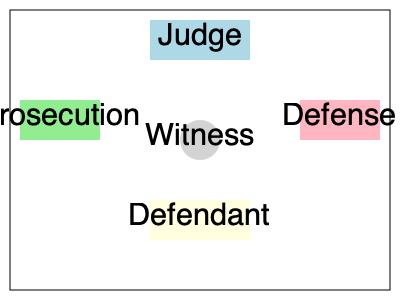In an international immigration hearing, the courtroom is arranged as shown in the diagram. If the judge needs to maintain direct line of sight with all parties, and the witness stand needs to be repositioned to accommodate a language interpreter, which position would be most suitable for the interpreter without obstructing the judge's view? To solve this problem, we need to consider the following steps:

1. Identify the current positions of all parties in the courtroom:
   - Judge: Center-top
   - Prosecution: Left side
   - Defense: Right side
   - Defendant: Center-bottom
   - Witness: Center

2. Understand the requirements:
   - The judge must maintain a direct line of sight with all parties
   - The interpreter needs to be positioned near the witness stand
   - The interpreter should not obstruct the judge's view

3. Analyze potential positions for the interpreter:
   a) To the left of the witness: This might obstruct the judge's view of the prosecution
   b) To the right of the witness: This might obstruct the judge's view of the defense
   c) Behind the witness: This would not obstruct any lines of sight
   d) In front of the witness: This would obstruct the judge's view of the defendant

4. Consider the practical aspects of interpretation:
   - The interpreter needs to be close enough to hear the witness clearly
   - The interpreter should not interfere with the witness's ability to see and be seen by other parties

5. Conclude the most suitable position:
   The optimal position for the interpreter would be slightly behind and to the side of the witness stand. This allows the interpreter to hear the witness clearly, maintain proximity for effective interpretation, and avoid obstructing any lines of sight between the judge and other parties in the courtroom.
Answer: Slightly behind and to the side of the witness stand 